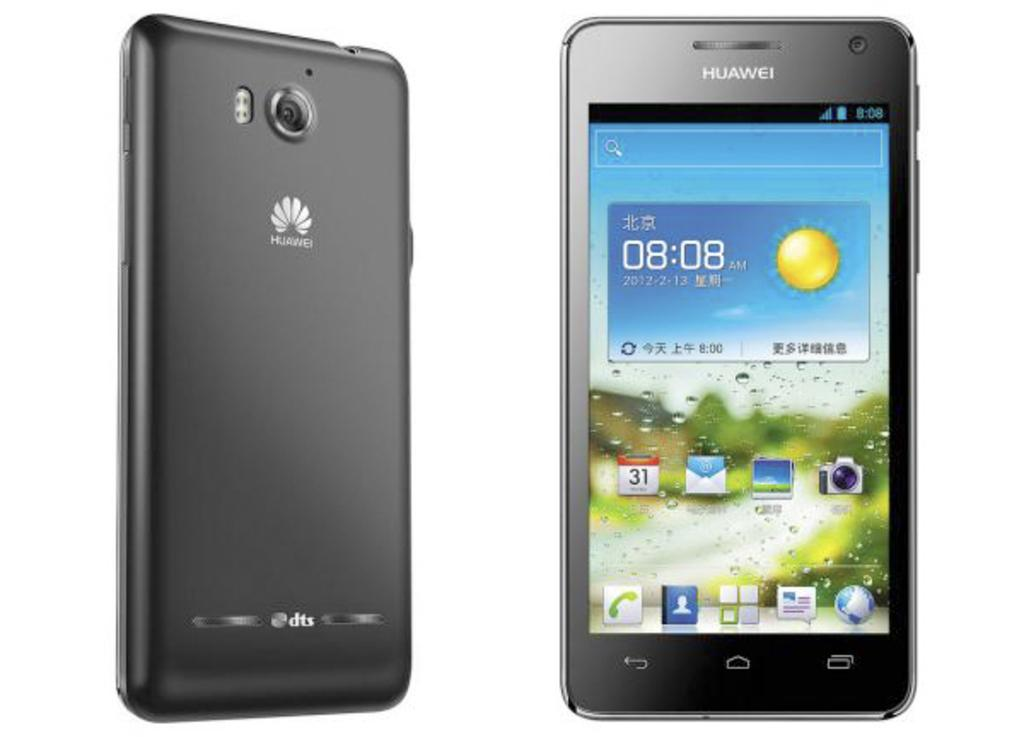<image>
Present a compact description of the photo's key features. An ad showing the front and back of a HUAWEI cellphone. 